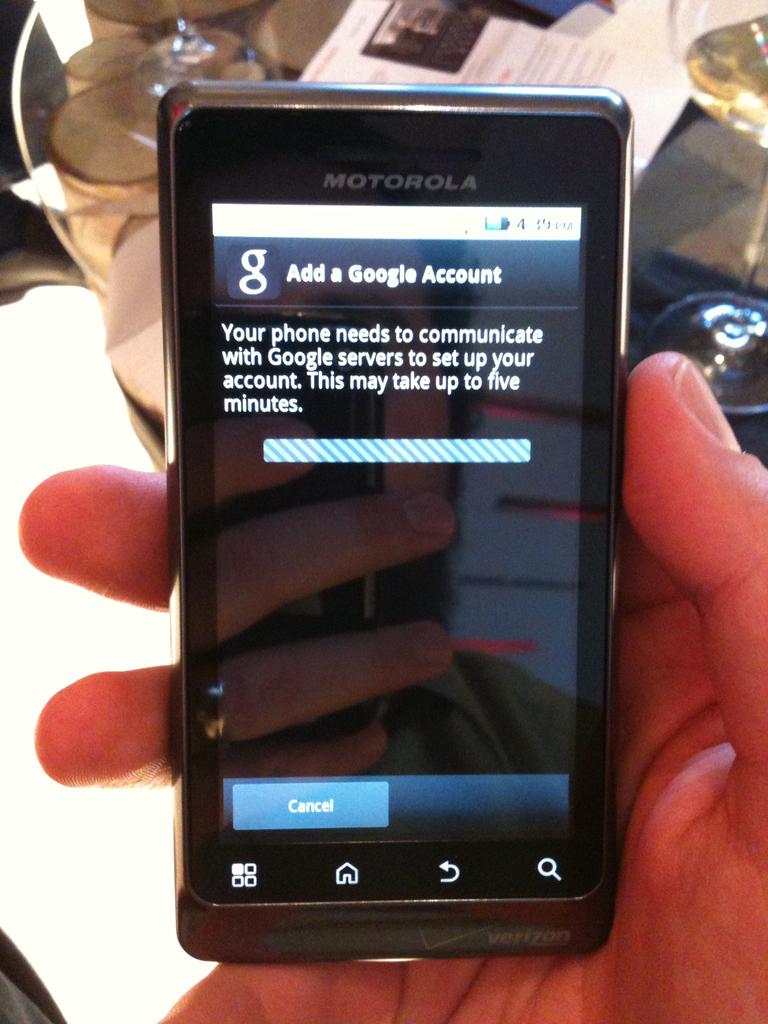What is the brand of the phone?
Your response must be concise. Motorola. 